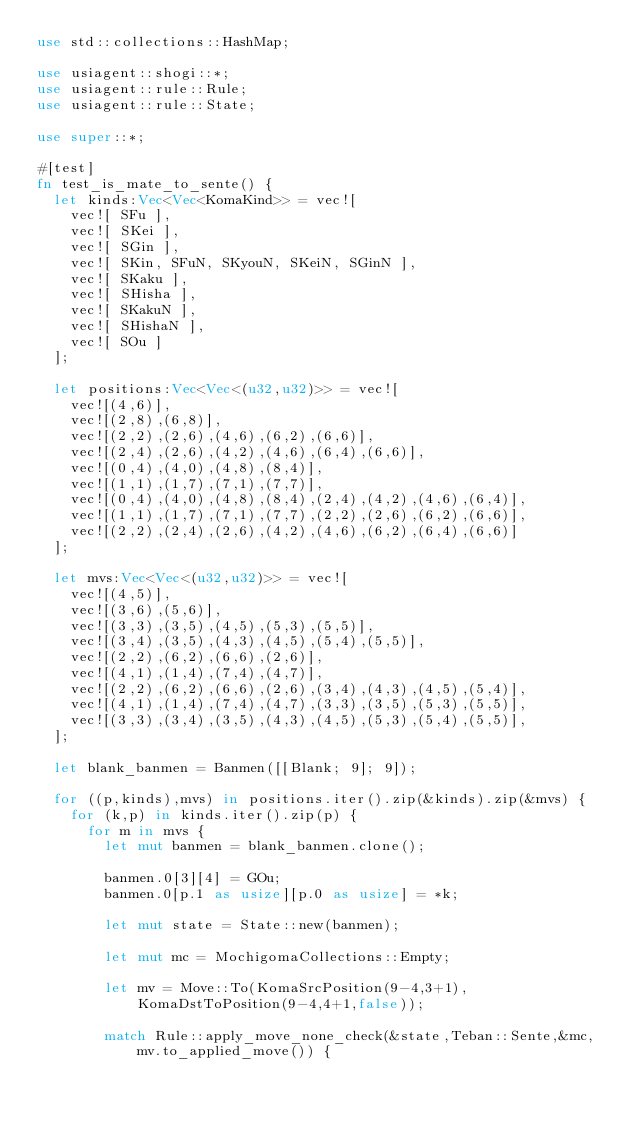<code> <loc_0><loc_0><loc_500><loc_500><_Rust_>use std::collections::HashMap;

use usiagent::shogi::*;
use usiagent::rule::Rule;
use usiagent::rule::State;

use super::*;

#[test]
fn test_is_mate_to_sente() {
	let kinds:Vec<Vec<KomaKind>> = vec![
		vec![ SFu ],
		vec![ SKei ],
		vec![ SGin ],
		vec![ SKin, SFuN, SKyouN, SKeiN, SGinN ],
		vec![ SKaku ],
		vec![ SHisha ],
		vec![ SKakuN ],
		vec![ SHishaN ],
		vec![ SOu ]
	];

	let positions:Vec<Vec<(u32,u32)>> = vec![
		vec![(4,6)],
		vec![(2,8),(6,8)],
		vec![(2,2),(2,6),(4,6),(6,2),(6,6)],
		vec![(2,4),(2,6),(4,2),(4,6),(6,4),(6,6)],
		vec![(0,4),(4,0),(4,8),(8,4)],
		vec![(1,1),(1,7),(7,1),(7,7)],
		vec![(0,4),(4,0),(4,8),(8,4),(2,4),(4,2),(4,6),(6,4)],
		vec![(1,1),(1,7),(7,1),(7,7),(2,2),(2,6),(6,2),(6,6)],
		vec![(2,2),(2,4),(2,6),(4,2),(4,6),(6,2),(6,4),(6,6)]
	];

	let mvs:Vec<Vec<(u32,u32)>> = vec![
		vec![(4,5)],
		vec![(3,6),(5,6)],
		vec![(3,3),(3,5),(4,5),(5,3),(5,5)],
		vec![(3,4),(3,5),(4,3),(4,5),(5,4),(5,5)],
		vec![(2,2),(6,2),(6,6),(2,6)],
		vec![(4,1),(1,4),(7,4),(4,7)],
		vec![(2,2),(6,2),(6,6),(2,6),(3,4),(4,3),(4,5),(5,4)],
		vec![(4,1),(1,4),(7,4),(4,7),(3,3),(3,5),(5,3),(5,5)],
		vec![(3,3),(3,4),(3,5),(4,3),(4,5),(5,3),(5,4),(5,5)],
	];

	let blank_banmen = Banmen([[Blank; 9]; 9]);

	for ((p,kinds),mvs) in positions.iter().zip(&kinds).zip(&mvs) {
		for (k,p) in kinds.iter().zip(p) {
			for m in mvs {
				let mut banmen = blank_banmen.clone();

				banmen.0[3][4] = GOu;
				banmen.0[p.1 as usize][p.0 as usize] = *k;

				let mut state = State::new(banmen);

				let mut mc = MochigomaCollections::Empty;

				let mv = Move::To(KomaSrcPosition(9-4,3+1),KomaDstToPosition(9-4,4+1,false));

				match Rule::apply_move_none_check(&state,Teban::Sente,&mc,mv.to_applied_move()) {</code> 